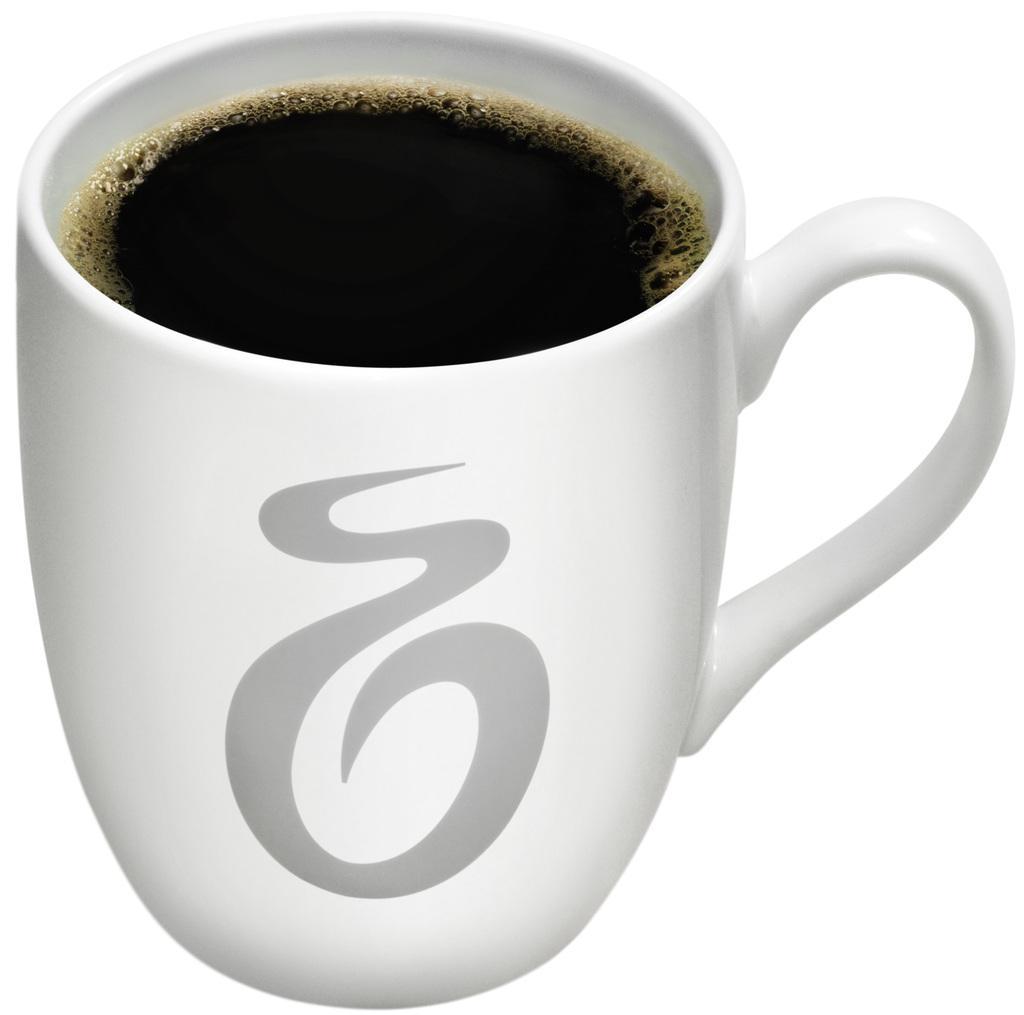Can you describe this image briefly? In this image there is a cup. There is a drink in the cup. There is foam on the drink. There is a symbol on the cup. The background is white. 